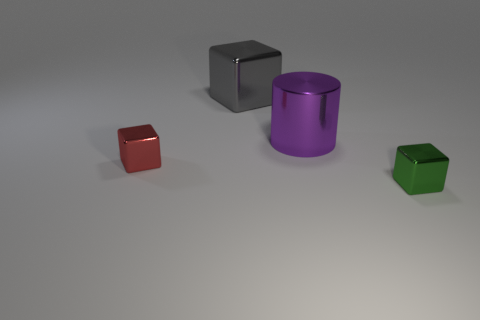Subtract all small red metal blocks. How many blocks are left? 2 Subtract all brown cylinders. How many green blocks are left? 1 Add 3 small things. How many small things exist? 5 Add 2 large purple things. How many objects exist? 6 Subtract all red cubes. How many cubes are left? 2 Subtract 0 blue cylinders. How many objects are left? 4 Subtract all cubes. How many objects are left? 1 Subtract all brown blocks. Subtract all green cylinders. How many blocks are left? 3 Subtract all tiny red blocks. Subtract all large gray cubes. How many objects are left? 2 Add 2 red shiny things. How many red shiny things are left? 3 